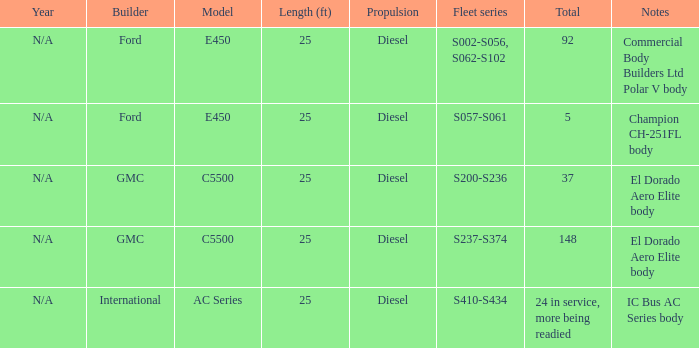Which model with a range series of s410-s434? AC Series. 